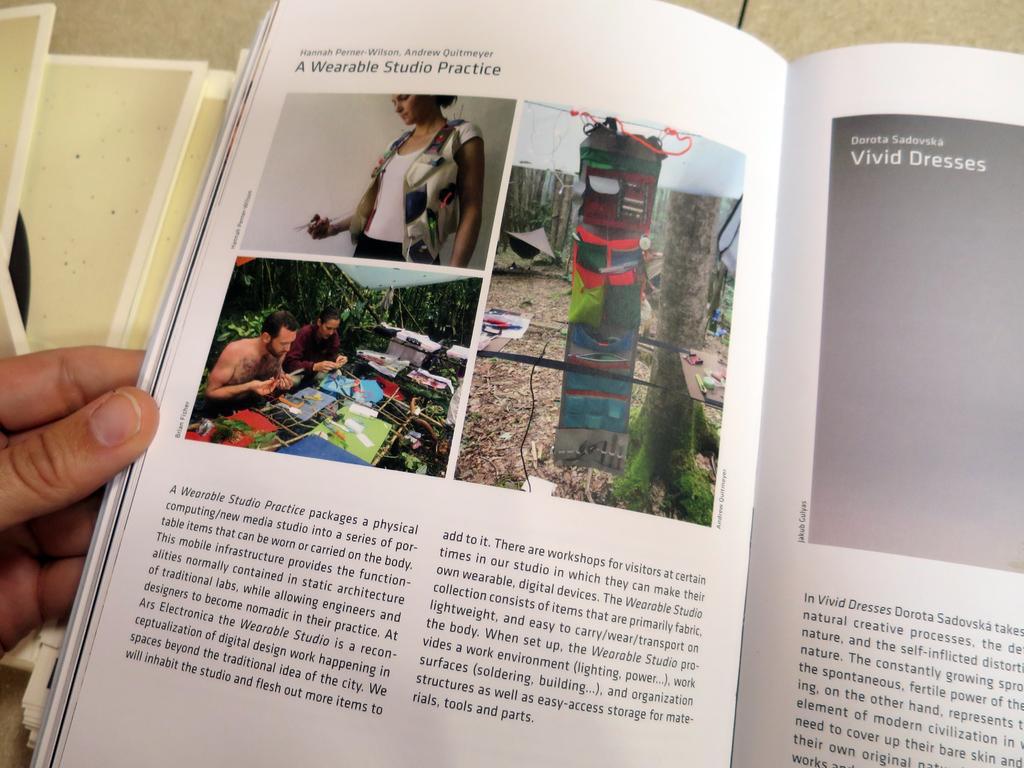In one or two sentences, can you explain what this image depicts? In this picture we can see a person's hand, book on the surface and in this book we can see some people, trees, some objects and some text. 